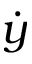<formula> <loc_0><loc_0><loc_500><loc_500>\dot { y }</formula> 